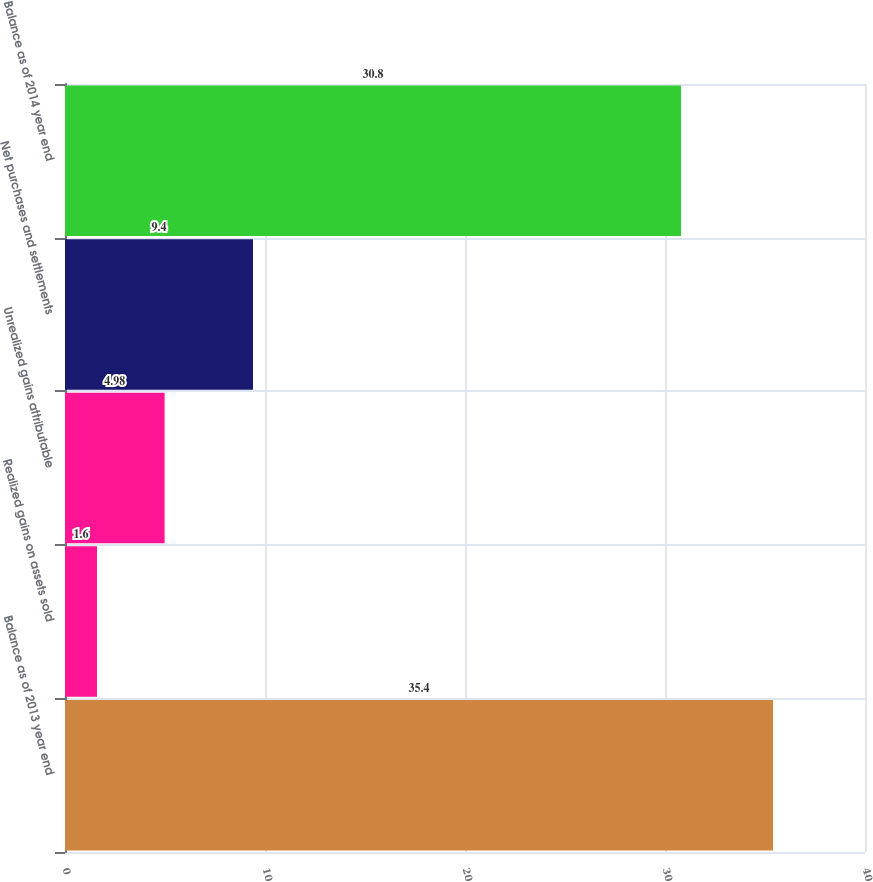Convert chart. <chart><loc_0><loc_0><loc_500><loc_500><bar_chart><fcel>Balance as of 2013 year end<fcel>Realized gains on assets sold<fcel>Unrealized gains attributable<fcel>Net purchases and settlements<fcel>Balance as of 2014 year end<nl><fcel>35.4<fcel>1.6<fcel>4.98<fcel>9.4<fcel>30.8<nl></chart> 